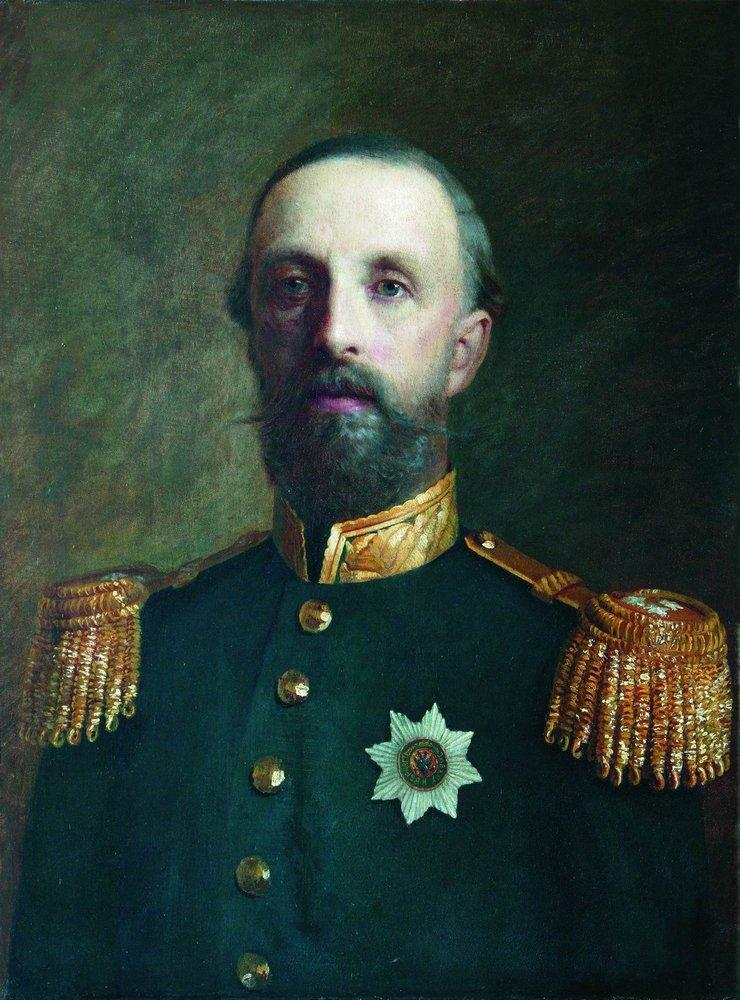What might the color and style of his uniform tell us about the time period or his rank? The dark blue color and style of the uniform, complete with gold epaulettes and decorations, are characteristic of military dress uniforms from the late 19th to early 20th century. This style was particularly prevalent among European navies and armies. The elaborate nature of the uniform, including its decorative epaulettes, suggests a high-ranking officer, possibly a general or admiral, as such adornments were typically reserved for senior positions. 